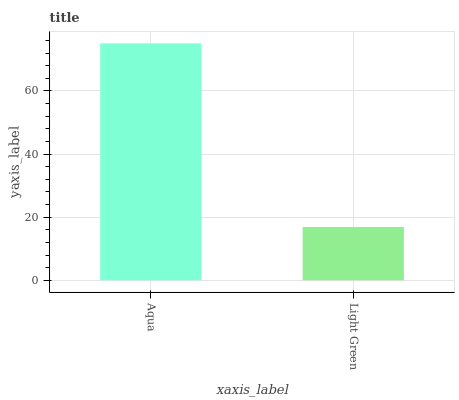Is Light Green the maximum?
Answer yes or no. No. Is Aqua greater than Light Green?
Answer yes or no. Yes. Is Light Green less than Aqua?
Answer yes or no. Yes. Is Light Green greater than Aqua?
Answer yes or no. No. Is Aqua less than Light Green?
Answer yes or no. No. Is Aqua the high median?
Answer yes or no. Yes. Is Light Green the low median?
Answer yes or no. Yes. Is Light Green the high median?
Answer yes or no. No. Is Aqua the low median?
Answer yes or no. No. 